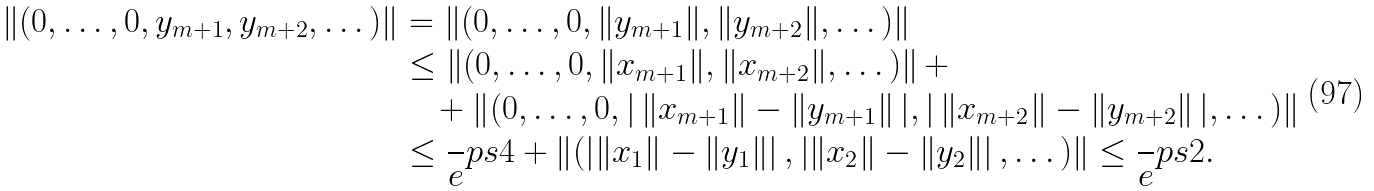Convert formula to latex. <formula><loc_0><loc_0><loc_500><loc_500>\| ( 0 , \dots , 0 , y _ { m + 1 } , y _ { m + 2 } , \dots ) \| & = \| ( 0 , \dots , 0 , \| y _ { m + 1 } \| , \| y _ { m + 2 } \| , \dots ) \| \\ & \leq \left \| ( 0 , \dots , 0 , \| x _ { m + 1 } \| , \| x _ { m + 2 } \| , \dots ) \right \| + \\ & \quad + \left \| ( 0 , \dots , 0 , \right | \| x _ { m + 1 } \| - \| y _ { m + 1 } \| \left | , \right | \| x _ { m + 2 } \| - \| y _ { m + 2 } \| \left | , \dots ) \right \| \\ & \leq \frac { \ } { e } p s 4 + \left \| ( \left | \| x _ { 1 } \| - \| y _ { 1 } \| \right | , \left | \| x _ { 2 } \| - \| y _ { 2 } \| \right | , \dots ) \right \| \leq \frac { \ } { e } p s 2 .</formula> 